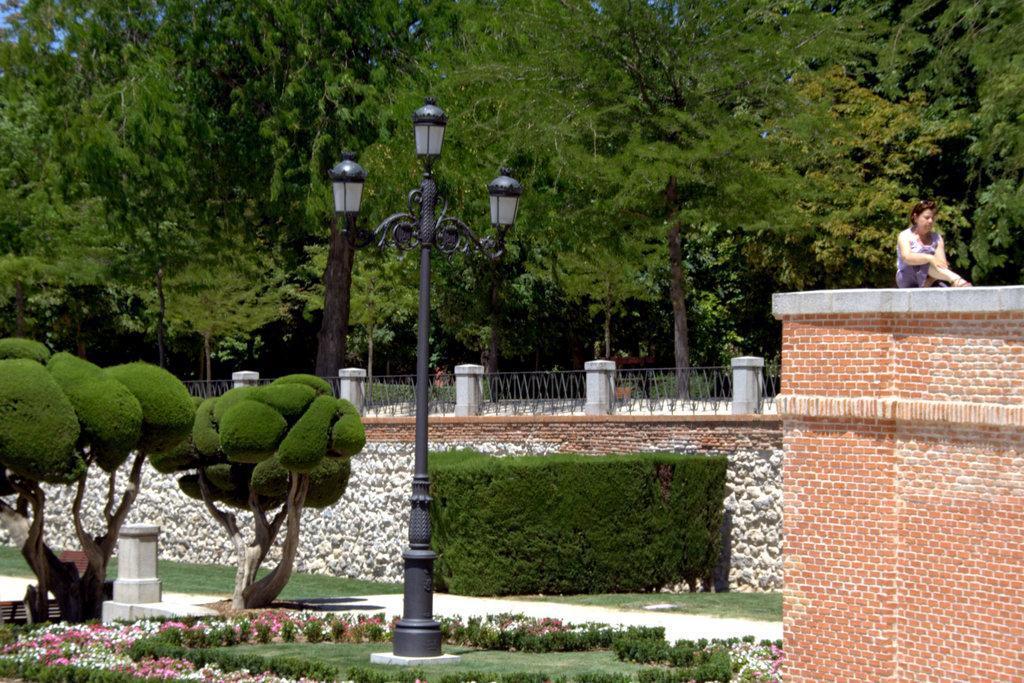In one or two sentences, can you explain what this image depicts? In this image we can see some trees, plants, grass, flowers, lights, fence, pole and the wall, also we can see a person sitting on the building. 